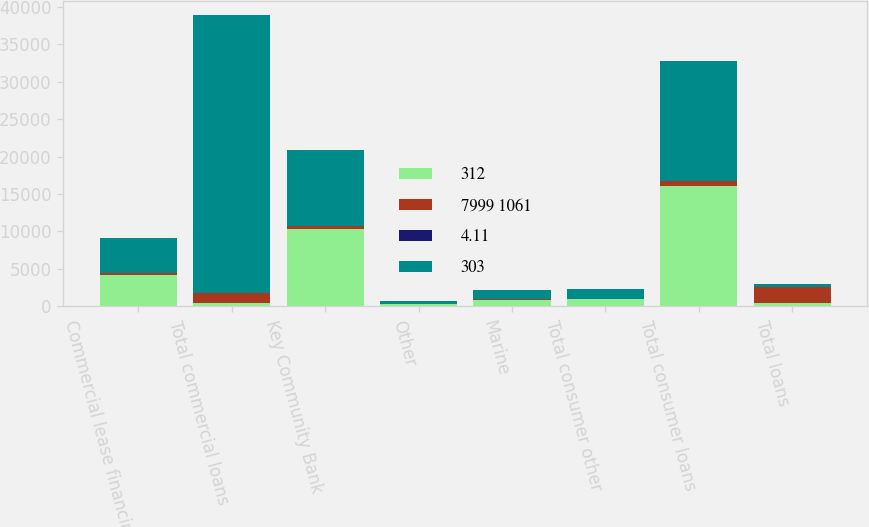Convert chart. <chart><loc_0><loc_0><loc_500><loc_500><stacked_bar_chart><ecel><fcel>Commercial lease financing<fcel>Total commercial loans<fcel>Key Community Bank<fcel>Other<fcel>Marine<fcel>Total consumer other<fcel>Total consumer loans<fcel>Total loans<nl><fcel>312<fcel>4239<fcel>405<fcel>10340<fcel>299<fcel>894<fcel>952<fcel>16005<fcel>405<nl><fcel>7999 1061<fcel>156<fcel>1368<fcel>405<fcel>23<fcel>56<fcel>60<fcel>766<fcel>2134<nl><fcel>4.11<fcel>3.67<fcel>3.45<fcel>3.91<fcel>7.8<fcel>6.22<fcel>6.31<fcel>4.79<fcel>3.83<nl><fcel>303<fcel>4683<fcel>37055<fcel>10086<fcel>377<fcel>1172<fcel>1246<fcel>15999<fcel>405<nl></chart> 